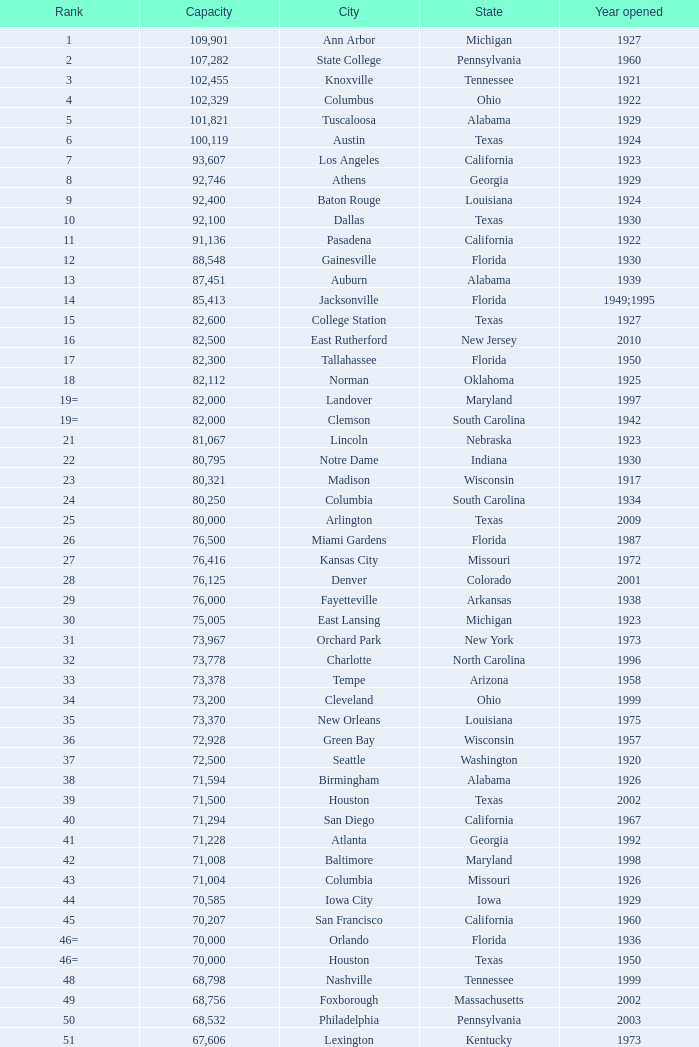What is the least capacity for 1903? 30323.0. 